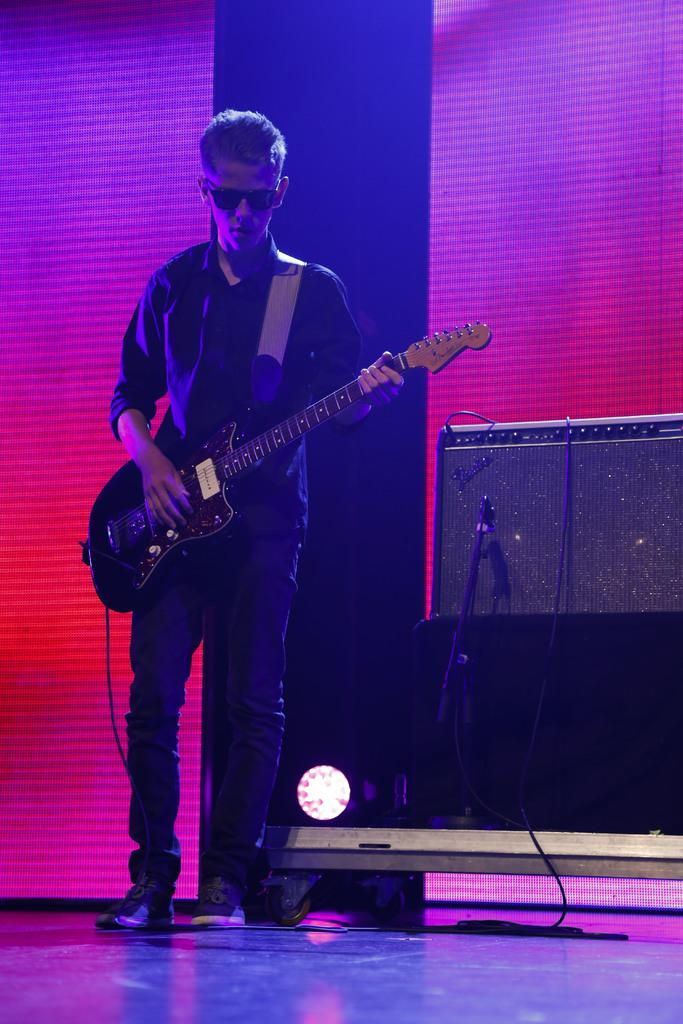What is the man in the image doing? The man is playing a guitar in the image. What can be seen in the background of the image? There is a microphone, a sound system, and lights in the background. What might the man be performing for in the image? The presence of a microphone and sound system suggests that the man might be performing for an audience. What type of beef is being served in the image? There is no beef present in the image; it features a man playing a guitar with a microphone, sound system, and lights in the background. What is the acoustics of the room like in the image? The image does not provide information about the acoustics of the room, as it focuses on the man playing the guitar and the equipment in the background. 